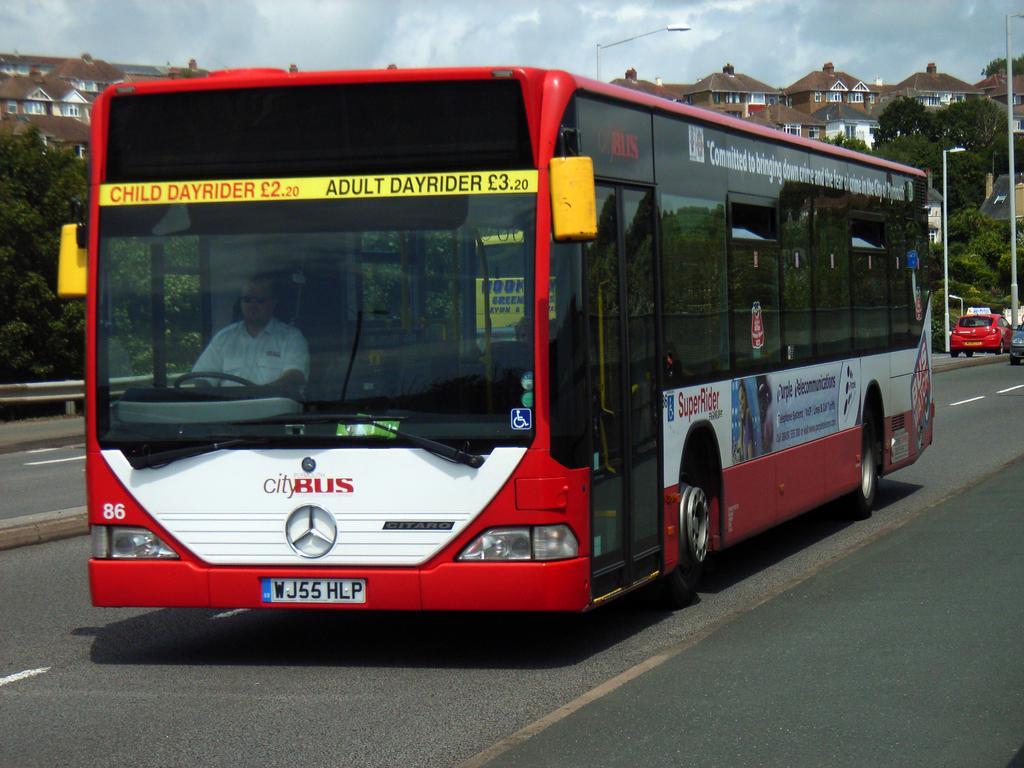Please provide a concise description of this image. At the top there is a sky. In the background we can see buildings and trees. We can see a red color bus and a person through glass. We can also see vehicles on the road. Here we can see lights with poles. 